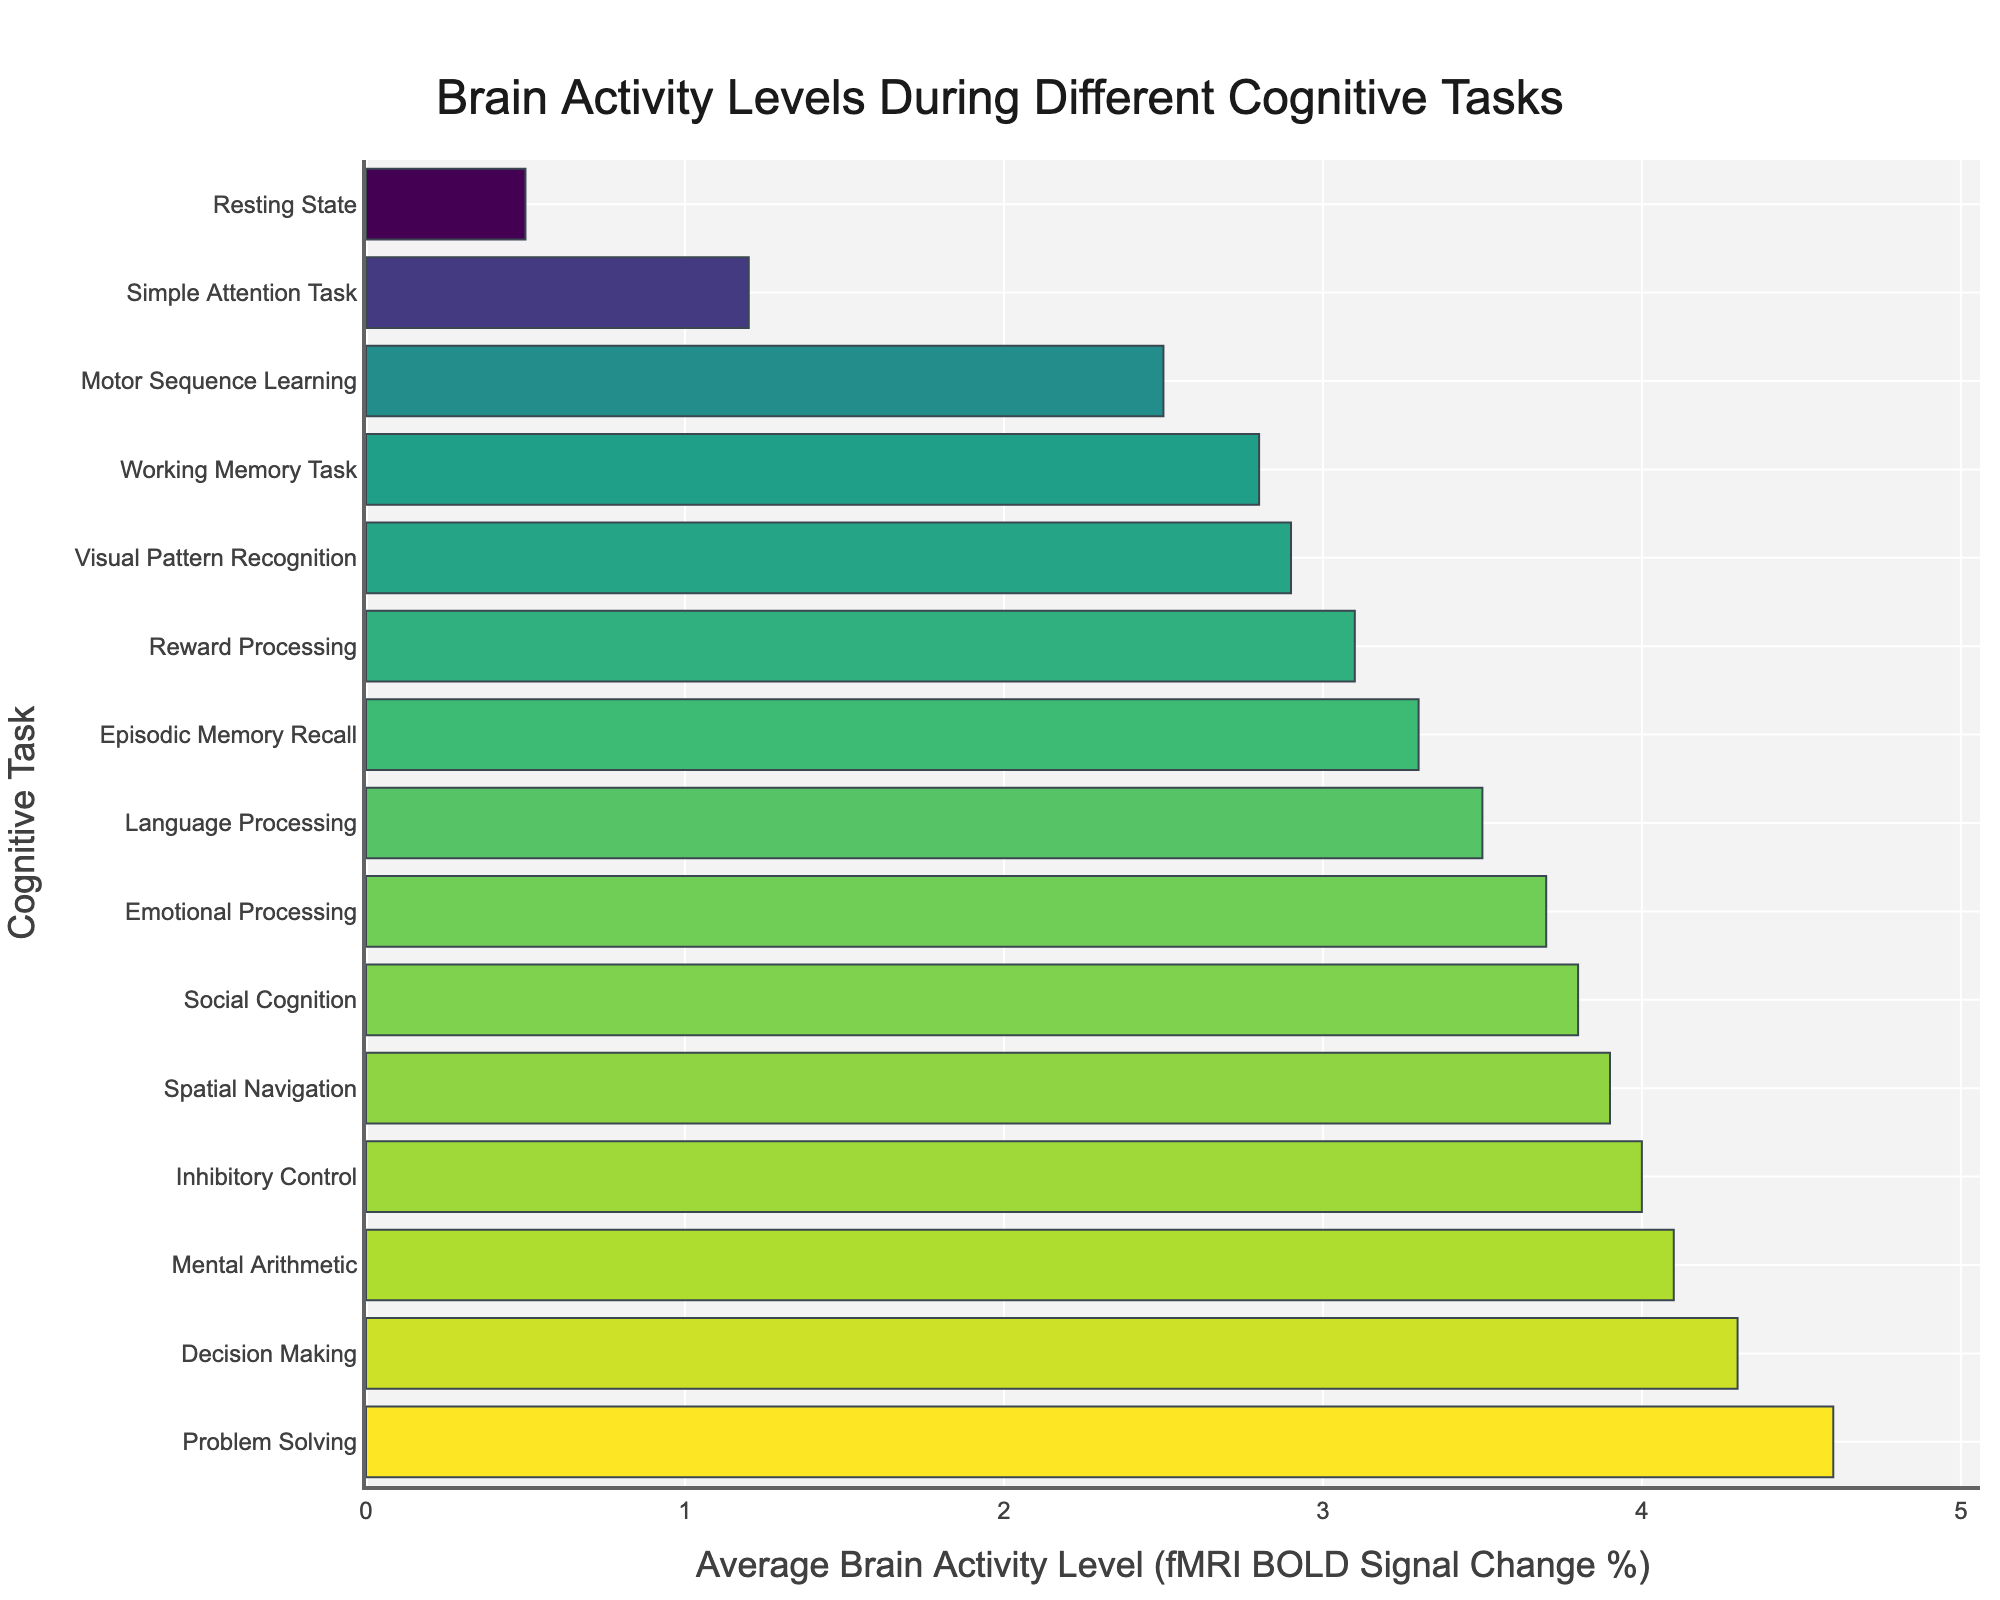Which cognitive task has the highest average brain activity level? Identify the cognitive task with the largest bar. The longest bar corresponds to "Problem Solving" with a value of 4.6.
Answer: Problem Solving Which cognitive task has the lowest average brain activity level? Identify the cognitive task with the smallest bar. The shortest bar corresponds to "Resting State" with a value of 0.5.
Answer: Resting State Compare the average brain activity levels between "Language Processing" and "Social Cognition". Which one is higher and by how much? Locate the bars for "Language Processing" and "Social Cognition". The values are 3.5 and 3.8, respectively. Subtract the smaller value from the larger one: 3.8 - 3.5 = 0.3.
Answer: Social Cognition, by 0.3 What is the sum of the average brain activity levels for "Decision Making", "Problem Solving", and "Visual Pattern Recognition"? Identify the values for each of these tasks: "Decision Making" (4.3), "Problem Solving" (4.6), and "Visual Pattern Recognition" (2.9). Sum them up: 4.3 + 4.6 + 2.9 = 11.8.
Answer: 11.8 What is the average brain activity level across all cognitive tasks presented? Sum the values of all cognitive tasks and divide by the number of tasks. The values are: 0.5, 1.2, 2.8, 3.5, 4.1, 3.9, 4.3, 3.7, 4.6, 2.9, 3.3, 2.5, 3.1, 3.8, 4.0. The total sum is 48.2, and there are 15 tasks. The average is 48.2/15 = 3.2133.
Answer: 3.2 Is the brain activity level for "Inhibitory Control" higher than for "Episodic Memory Recall"? Identify the values for "Inhibitory Control" (4.0) and "Episodic Memory Recall" (3.3) and compare them. Since 4.0 > 3.3, "Inhibitory Control" is higher.
Answer: Yes How does the average brain activity level of "Motor Sequence Learning" compare to that of "Working Memory Task"? Locate the values for "Motor Sequence Learning" (2.5) and "Working Memory Task" (2.8). Compare the two values. 2.8 is greater than 2.5.
Answer: Working Memory Task is higher What is the difference in brain activity levels between "Reward Processing" and "Simple Attention Task"? Identify the values for "Reward Processing" (3.1) and "Simple Attention Task" (1.2). Subtract the smaller value from the larger one: 3.1 - 1.2 = 1.9.
Answer: 1.9 Which cognitive tasks have an average brain activity level greater than 3.0 but less than 4.0? Identify the tasks that fall within the range of 3.0 to 4.0. They are "Language Processing" (3.5), "Emotional Processing" (3.7), "Spatial Navigation" (3.9), "Episodic Memory Recall" (3.3), "Reward Processing" (3.1), and "Social Cognition" (3.8).
Answer: Language Processing, Emotional Processing, Spatial Navigation, Episodic Memory Recall, Reward Processing, Social Cognition How many cognitive tasks have a brain activity level below 2.0? Count the number of bars that have values below 2.0. These tasks are "Resting State" (0.5) and "Simple Attention Task" (1.2). There are two such tasks.
Answer: 2 